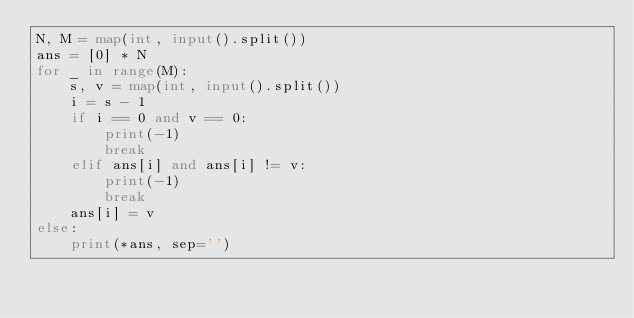<code> <loc_0><loc_0><loc_500><loc_500><_Python_>N, M = map(int, input().split())
ans = [0] * N
for _ in range(M):
	s, v = map(int, input().split())
	i = s - 1
	if i == 0 and v == 0:
		print(-1)
		break
	elif ans[i] and ans[i] != v:
		print(-1)
		break
	ans[i] = v
else:
	print(*ans, sep='')</code> 